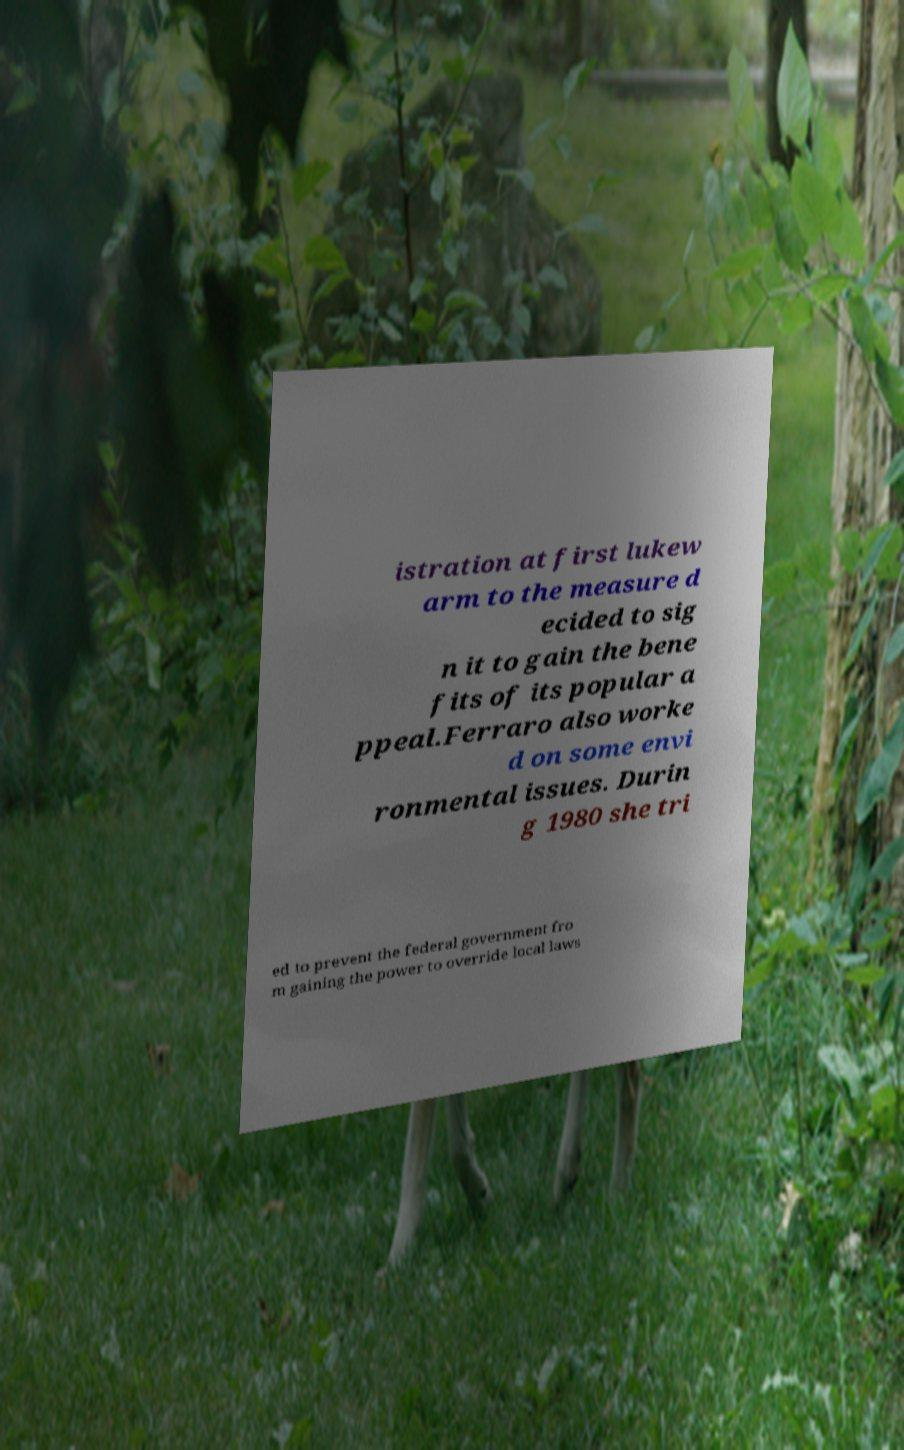Please read and relay the text visible in this image. What does it say? istration at first lukew arm to the measure d ecided to sig n it to gain the bene fits of its popular a ppeal.Ferraro also worke d on some envi ronmental issues. Durin g 1980 she tri ed to prevent the federal government fro m gaining the power to override local laws 